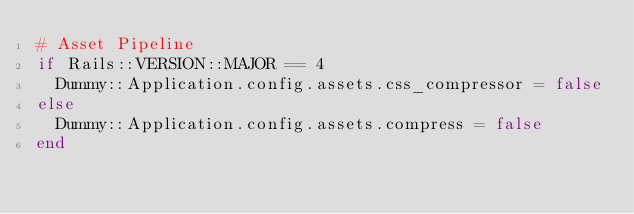<code> <loc_0><loc_0><loc_500><loc_500><_Ruby_># Asset Pipeline
if Rails::VERSION::MAJOR == 4
  Dummy::Application.config.assets.css_compressor = false
else
  Dummy::Application.config.assets.compress = false
end
</code> 